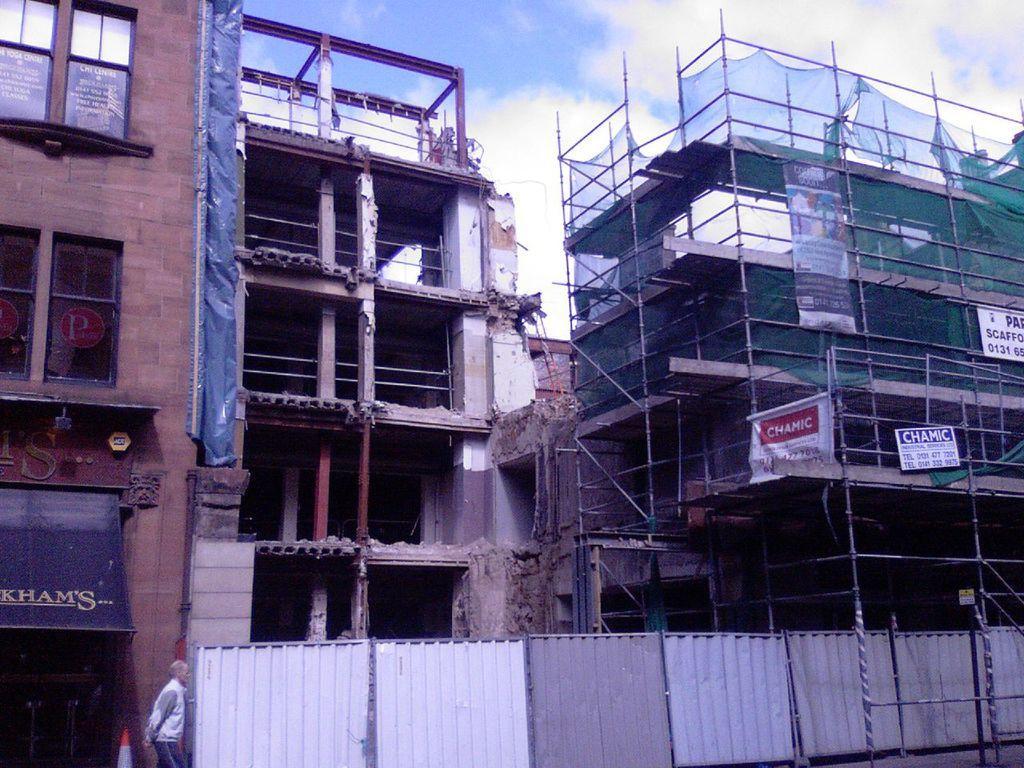Can you describe this image briefly? In this image I can see a person walking on the left. There are buildings at the back and construction is going on. There are banners on the left. There are tin sheets in the center. There is sky at the top. 